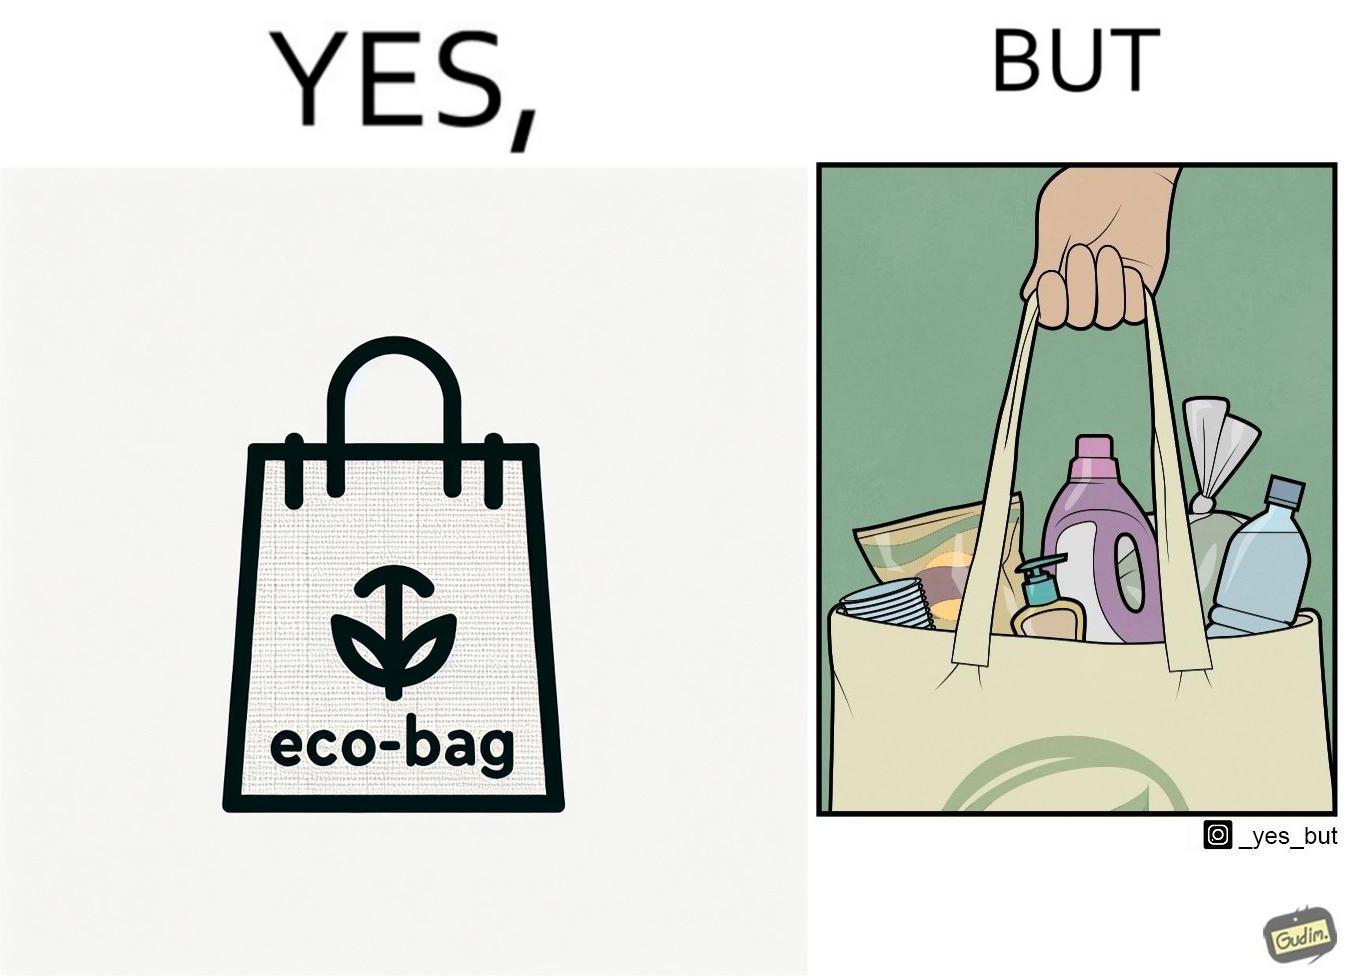Is there satirical content in this image? Yes, this image is satirical. 